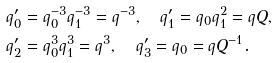<formula> <loc_0><loc_0><loc_500><loc_500>q ^ { \prime } _ { 0 } & = q _ { 0 } ^ { - 3 } q _ { 1 } ^ { - 3 } = q ^ { - 3 } , \quad q ^ { \prime } _ { 1 } = q _ { 0 } q _ { 1 } ^ { 2 } = q Q , \\ q ^ { \prime } _ { 2 } & = q _ { 0 } ^ { 3 } q _ { 1 } ^ { 3 } = q ^ { 3 } , \quad q ^ { \prime } _ { 3 } = q _ { 0 } = q Q ^ { - 1 } .</formula> 